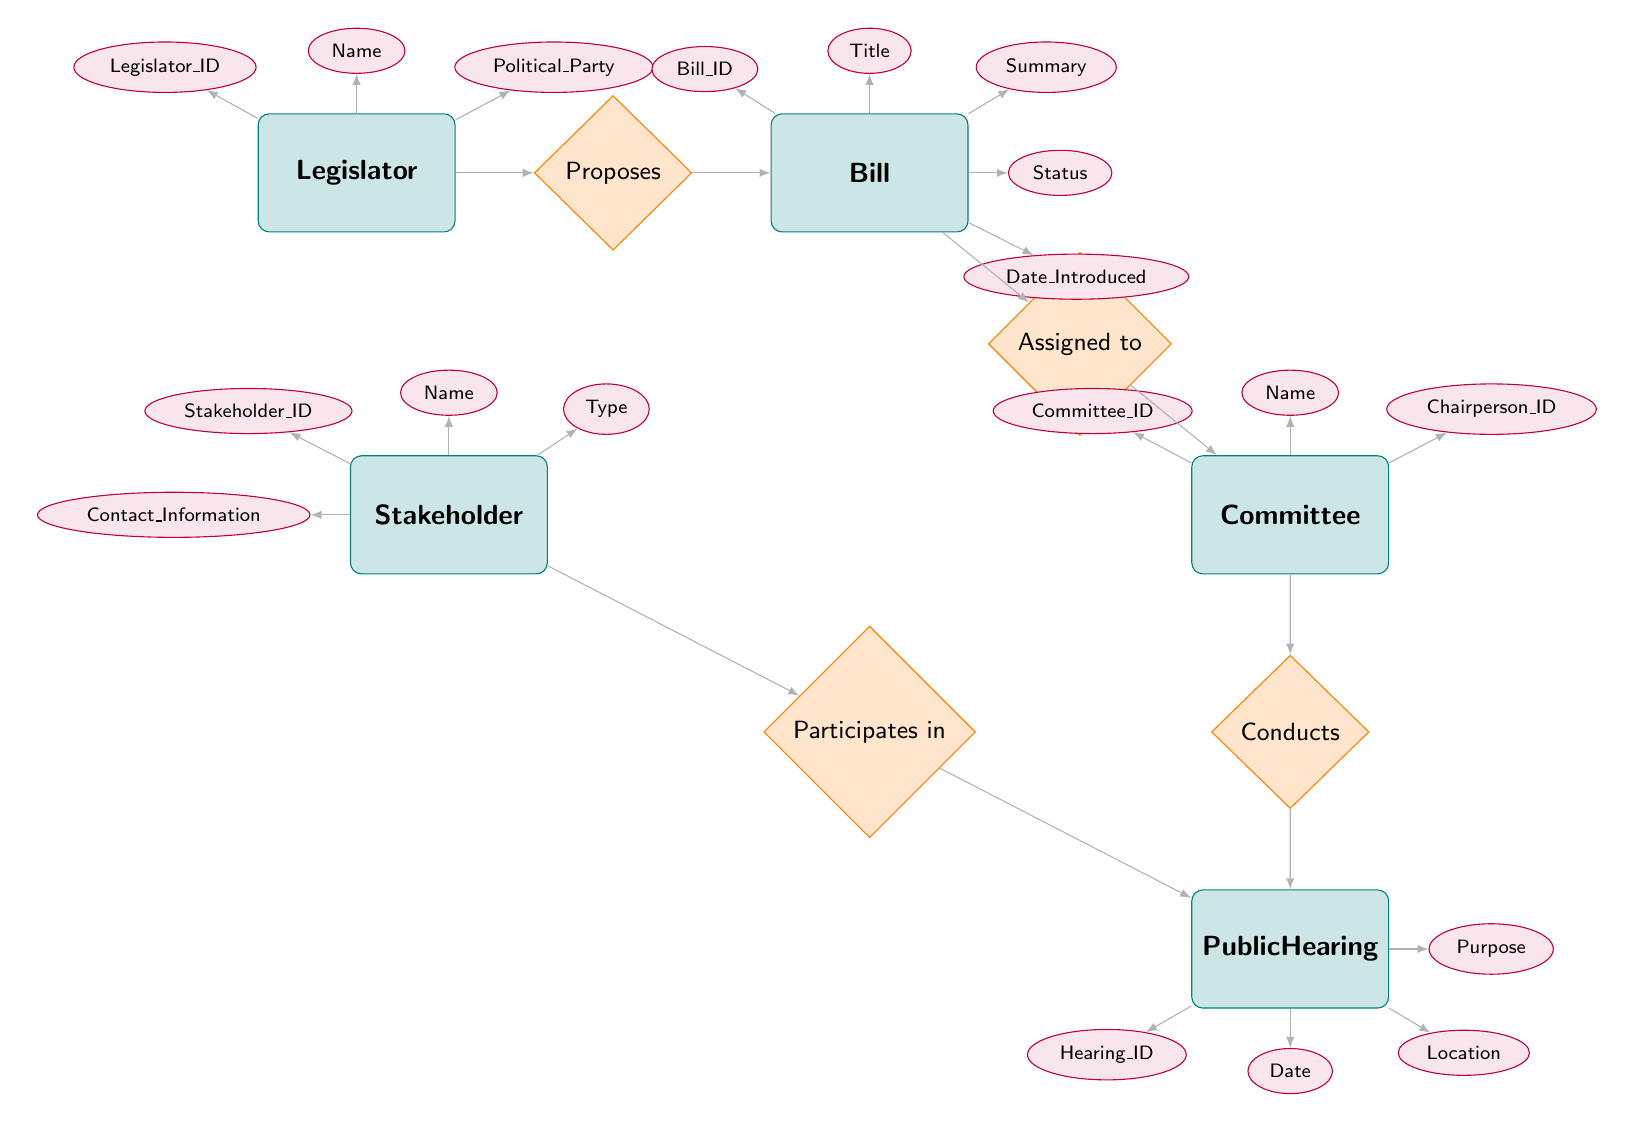What entity proposes a bill? The diagram shows that the relationship "Proposes" connects the "Legislator" entity to the "Bill" entity, indicating that the legislator is the one who proposes a bill.
Answer: Legislator How many attributes does the Stakeholder entity have? The "Stakeholder" entity has four attributes: Stakeholder_ID, Name, Type, and Contact_Information. By counting these, we find there are four in total.
Answer: 4 Which entity is assigned to the Bill? The relationship "Assigned to" connects the "Bill" entity to the "Committee" entity, meaning the committee is what is assigned to the bill.
Answer: Committee What relationship involves the Public Hearing entity? The Public Hearing entity is involved in two relationships: it is "Conducted" by the Committee and has Stakeholders that "Participate in" it. By reviewing these connections, we identify both relationships that involve the Public Hearing.
Answer: Conducts, Participates in How many entities are present in the diagram? The diagram contains five entities: Legislator, Bill, Committee, Stakeholder, and Public Hearing. By simply counting these entities from the visual, we find there are five in total.
Answer: 5 If a Stakeholder participates in a Public Hearing, what role do they have? The diagram shows that the relationship "Participates in," which connects Stakeholder to Public Hearing, includes an attribute labeled "Role." This indicates that each Stakeholder can have a specific role during their participation in the Public Hearing.
Answer: Role What is the Chairperson attribute associated with? The Chairperson_ID attribute is found in the Committee entity, indicating the individual who chairs the committee associated with bills. The relationship lines connect this attribute to its corresponding Committee entity.
Answer: Committee Which entity conducts the Public Hearing? The "Conducts" relationship connects the "Committee" entity to the "Public Hearing" entity, indicating that the committee is the one that conducts the public hearing.
Answer: Committee What is the purpose of the Public Hearing? The attribute "Purpose" associated with the Public Hearing entity indicates the reason or objective of the hearing held. This purpose is linked directly to the Public Hearing in the diagram.
Answer: Purpose 